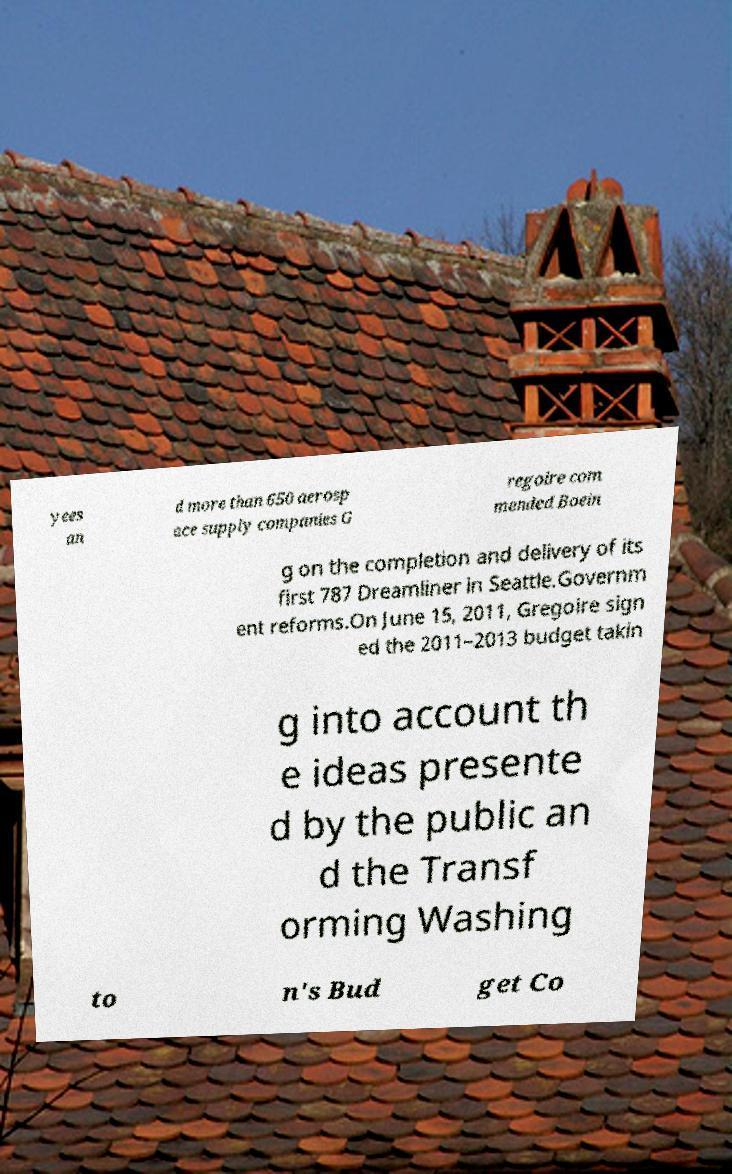For documentation purposes, I need the text within this image transcribed. Could you provide that? yees an d more than 650 aerosp ace supply companies G regoire com mended Boein g on the completion and delivery of its first 787 Dreamliner in Seattle.Governm ent reforms.On June 15, 2011, Gregoire sign ed the 2011–2013 budget takin g into account th e ideas presente d by the public an d the Transf orming Washing to n's Bud get Co 